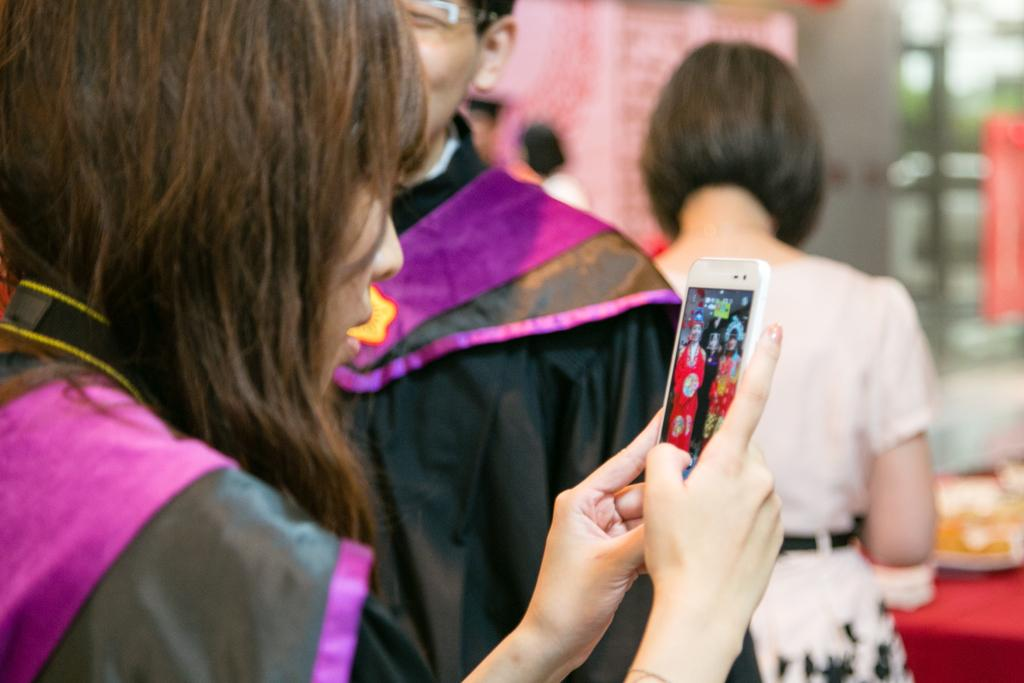What is the girl in the image doing? The girl in the image is using a mobile. Can you describe the man in the background of the image? The man in the background is wearing a black coat. Who else is present in the background of the image? There is a girl beside the man in the background. Can you see any rivers or icicles in the image? No, there are no rivers or icicles present in the image. Is there a baby visible in the image? No, there is no baby visible in the image. 